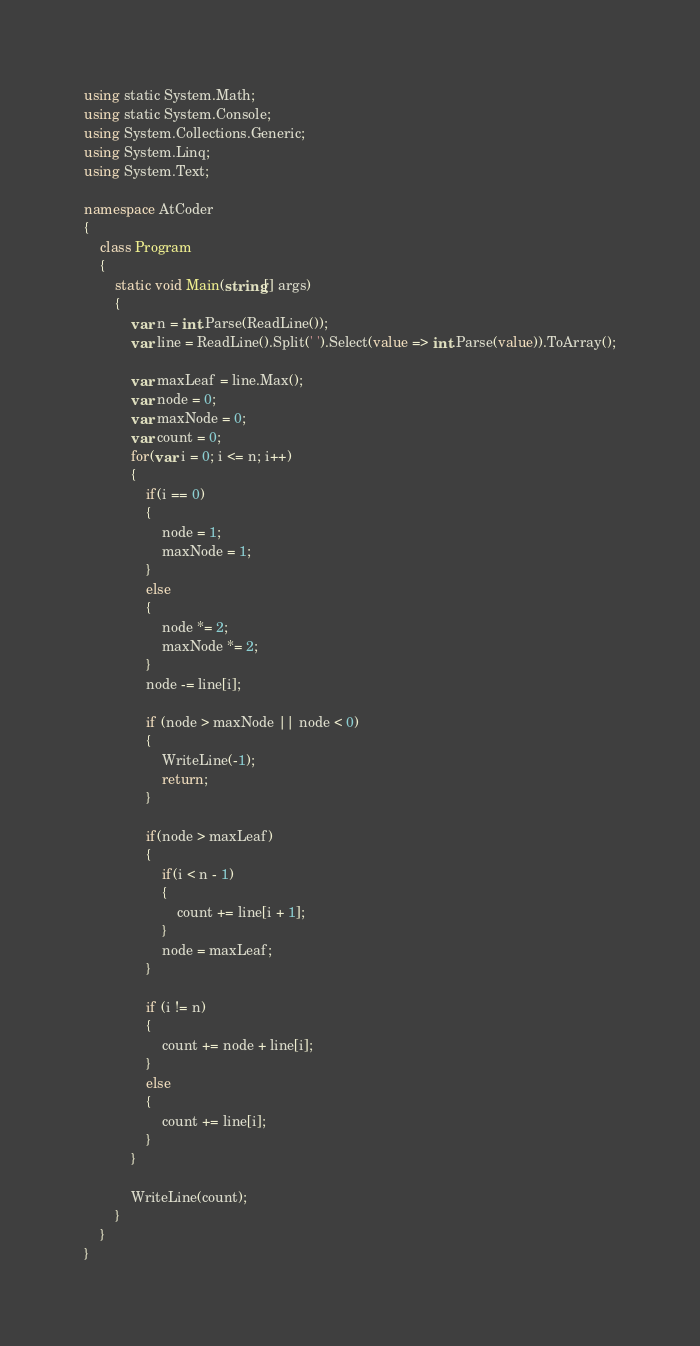<code> <loc_0><loc_0><loc_500><loc_500><_C#_>using static System.Math;
using static System.Console;
using System.Collections.Generic;
using System.Linq;
using System.Text;

namespace AtCoder
{
	class Program
	{
		static void Main(string[] args)
		{
			var n = int.Parse(ReadLine());
			var line = ReadLine().Split(' ').Select(value => int.Parse(value)).ToArray();

			var maxLeaf = line.Max();
			var node = 0;
			var maxNode = 0;
			var count = 0;
			for(var i = 0; i <= n; i++)
			{
				if(i == 0)
				{
					node = 1;
					maxNode = 1;
				}
				else
				{
					node *= 2;
					maxNode *= 2;
				}
				node -= line[i];

				if (node > maxNode || node < 0)
				{
					WriteLine(-1);
					return;
				}

				if(node > maxLeaf)
				{
					if(i < n - 1)
					{
						count += line[i + 1];
					}
					node = maxLeaf;
				}

				if (i != n)
				{
					count += node + line[i];
				}
				else
				{
					count += line[i];
				}
			}

			WriteLine(count);
		}
	}
}
</code> 